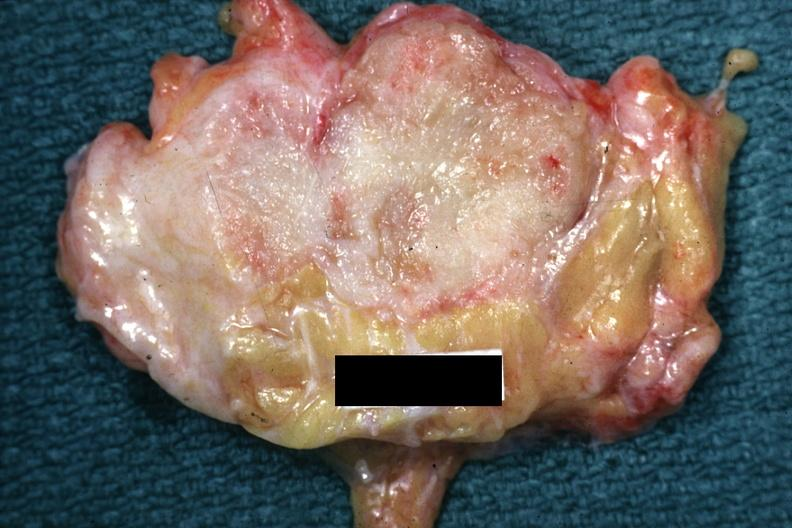s muscle atrophy present?
Answer the question using a single word or phrase. No 